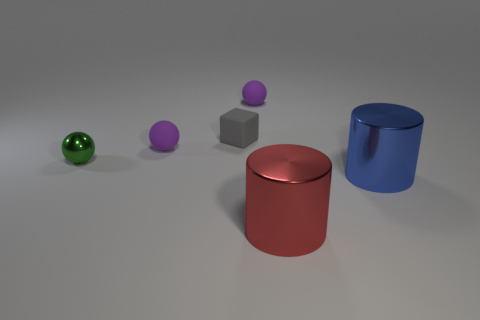How many other things are the same material as the gray thing?
Give a very brief answer. 2. Are there any large metallic cylinders that are right of the purple matte thing that is on the left side of the tiny gray rubber cube?
Offer a terse response. Yes. The object that is both in front of the small metallic sphere and behind the large red metallic thing is made of what material?
Provide a short and direct response. Metal. The tiny thing that is the same material as the big red object is what shape?
Your response must be concise. Sphere. Is there anything else that has the same shape as the small gray object?
Provide a short and direct response. No. Is the material of the cylinder that is on the left side of the big blue object the same as the small green sphere?
Keep it short and to the point. Yes. What is the big cylinder to the right of the red object made of?
Provide a succinct answer. Metal. What size is the object that is in front of the cylinder behind the red cylinder?
Offer a very short reply. Large. How many other blue metallic things are the same size as the blue thing?
Your answer should be compact. 0. There is a small sphere behind the gray block; is it the same color as the rubber sphere that is in front of the gray block?
Your answer should be compact. Yes. 